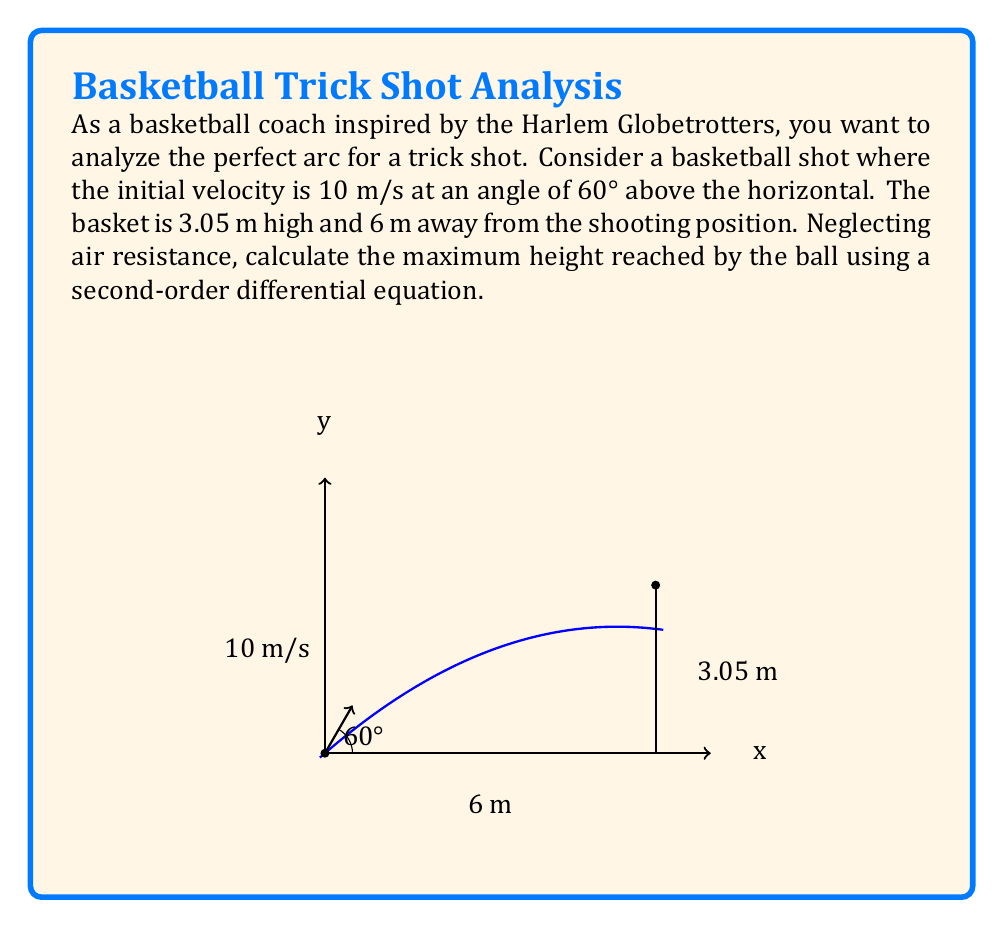Can you solve this math problem? Let's approach this step-by-step using a second-order differential equation:

1) The general form of the second-order differential equation for projectile motion is:

   $$\frac{d^2y}{dt^2} = -g$$

   where $g$ is the acceleration due to gravity (9.8 m/s²).

2) We can integrate this twice to get the position equation:

   $$y(t) = -\frac{1}{2}gt^2 + v_0\sin(\theta)t + y_0$$

   where $v_0$ is the initial velocity, $\theta$ is the launch angle, and $y_0$ is the initial height.

3) Given:
   $v_0 = 10$ m/s
   $\theta = 60°$
   $y_0 = 0$ m (assuming shot from ground level)

4) Substituting these values:

   $$y(t) = -4.9t^2 + 10\sin(60°)t + 0$$
   $$y(t) = -4.9t^2 + 8.66t$$

5) To find the maximum height, we need to find when the vertical velocity is zero:

   $$\frac{dy}{dt} = -9.8t + 8.66 = 0$$
   $$t = \frac{8.66}{9.8} = 0.884\text{ seconds}$$

6) Substitute this time back into the position equation:

   $$y_{max} = -4.9(0.884)^2 + 8.66(0.884)$$
   $$y_{max} = -3.83 + 7.66 = 3.83\text{ m}$$

Therefore, the maximum height reached by the ball is 3.83 meters.
Answer: 3.83 m 